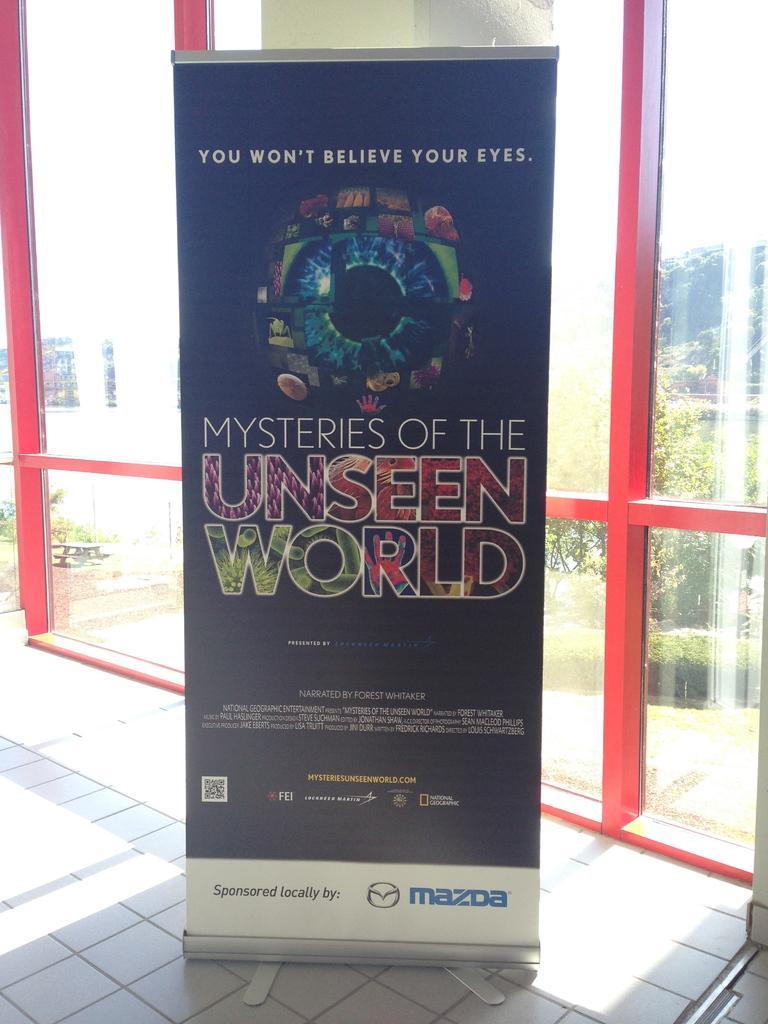Describe this image in one or two sentences. In this image we can see one poster attached to the glass wall, one glass wall with red poles, one white object on the right side of the image looks like a pole, one banner with text and images on the floor. Through the glass we can see one object on the ground, some pots with plants, some trees, bushes, plants and grass on the ground. At the top there is the sky. 